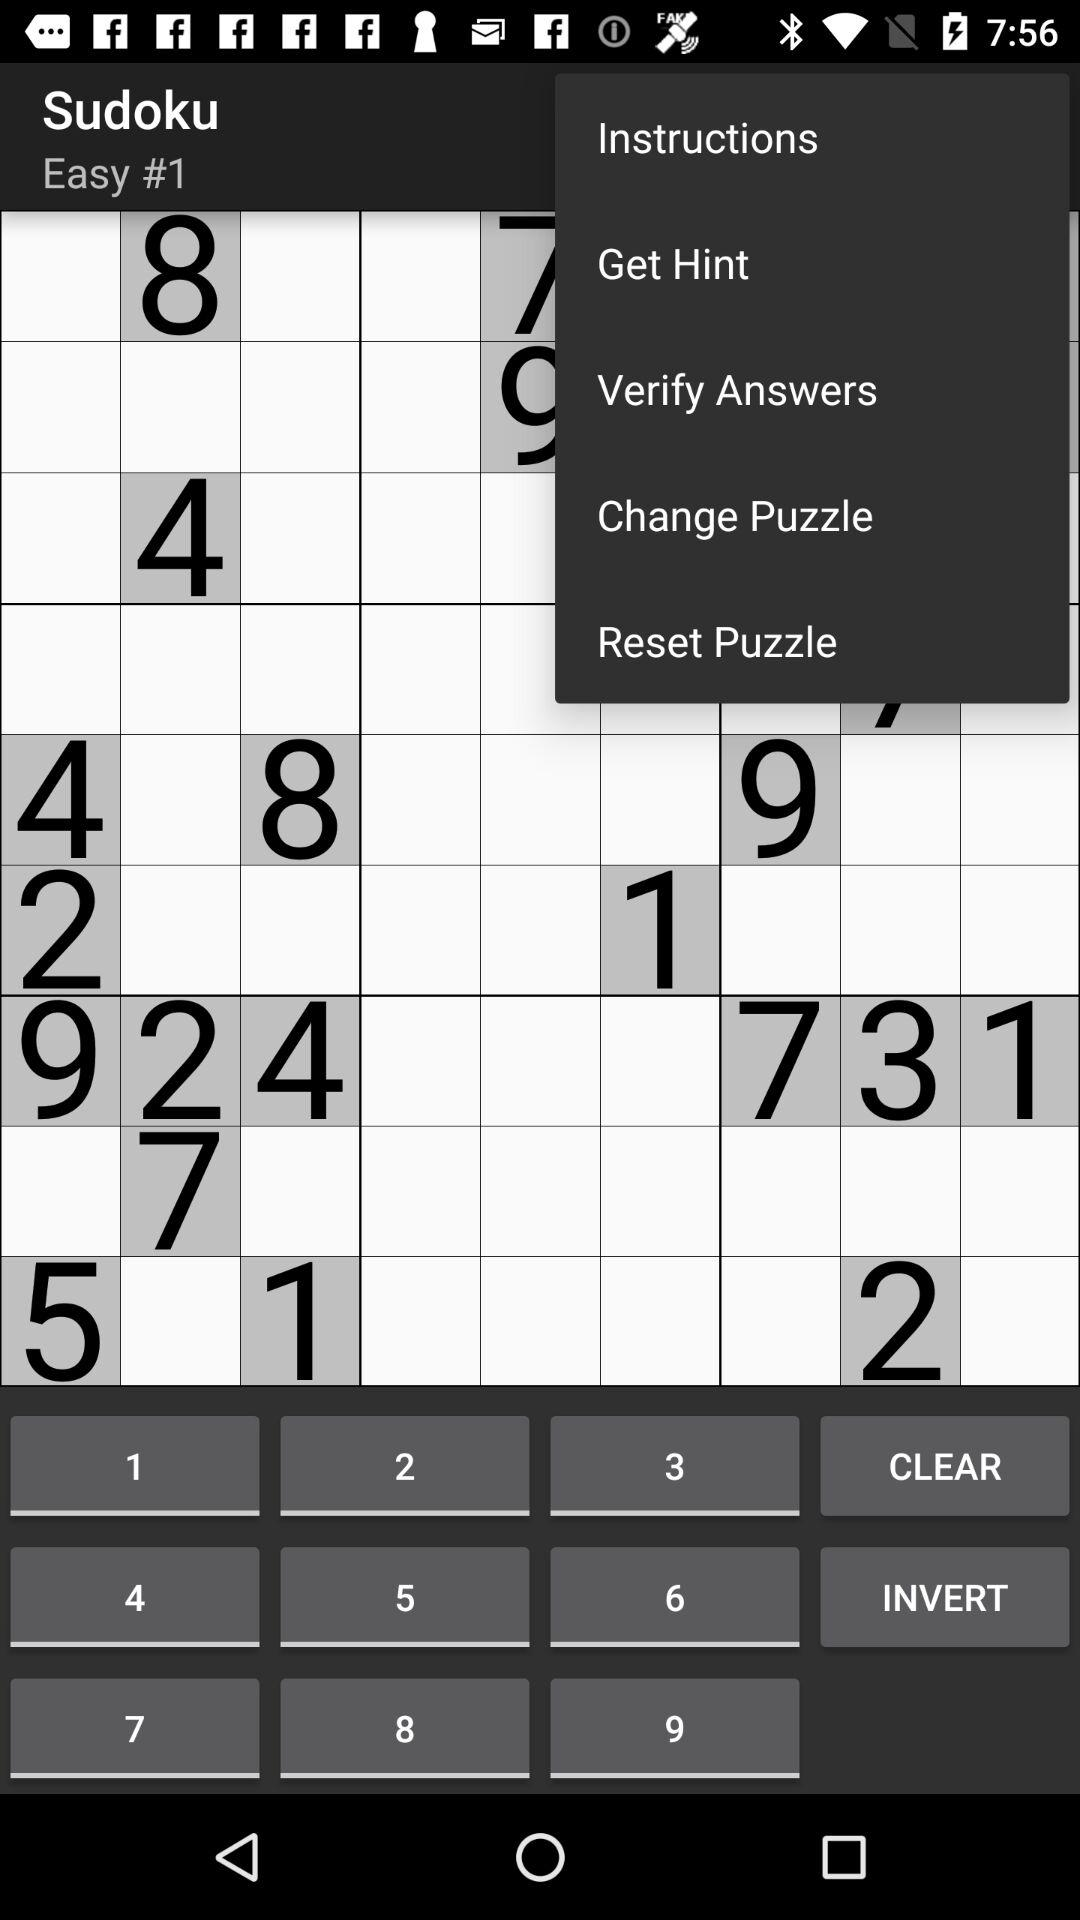What is the game name? The game name is "Sudoku". 